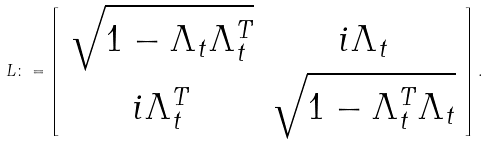<formula> <loc_0><loc_0><loc_500><loc_500>L \colon = \left [ \begin{array} { c c } \sqrt { 1 - \Lambda _ { t } \Lambda _ { t } ^ { T } } & i \Lambda _ { t } \\ i \Lambda _ { t } ^ { T } & \sqrt { { 1 } - \Lambda _ { t } ^ { T } \Lambda _ { t } } \end{array} \right ] .</formula> 